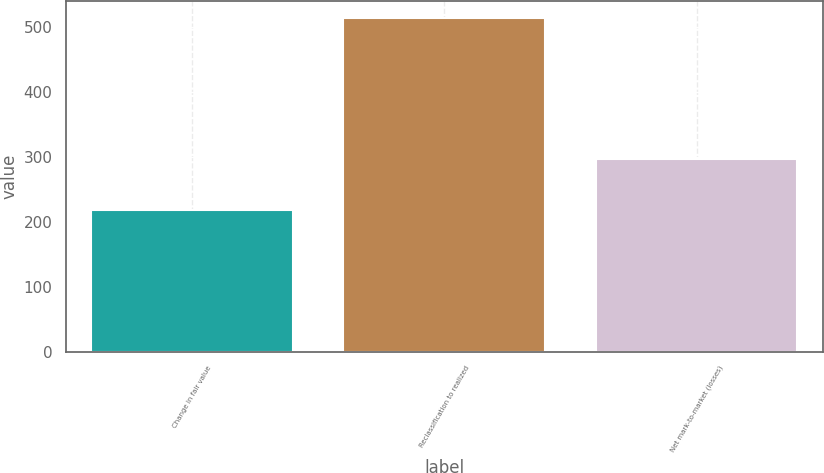Convert chart to OTSL. <chart><loc_0><loc_0><loc_500><loc_500><bar_chart><fcel>Change in fair value<fcel>Reclassification to realized<fcel>Net mark-to-market (losses)<nl><fcel>218<fcel>515<fcel>297<nl></chart> 